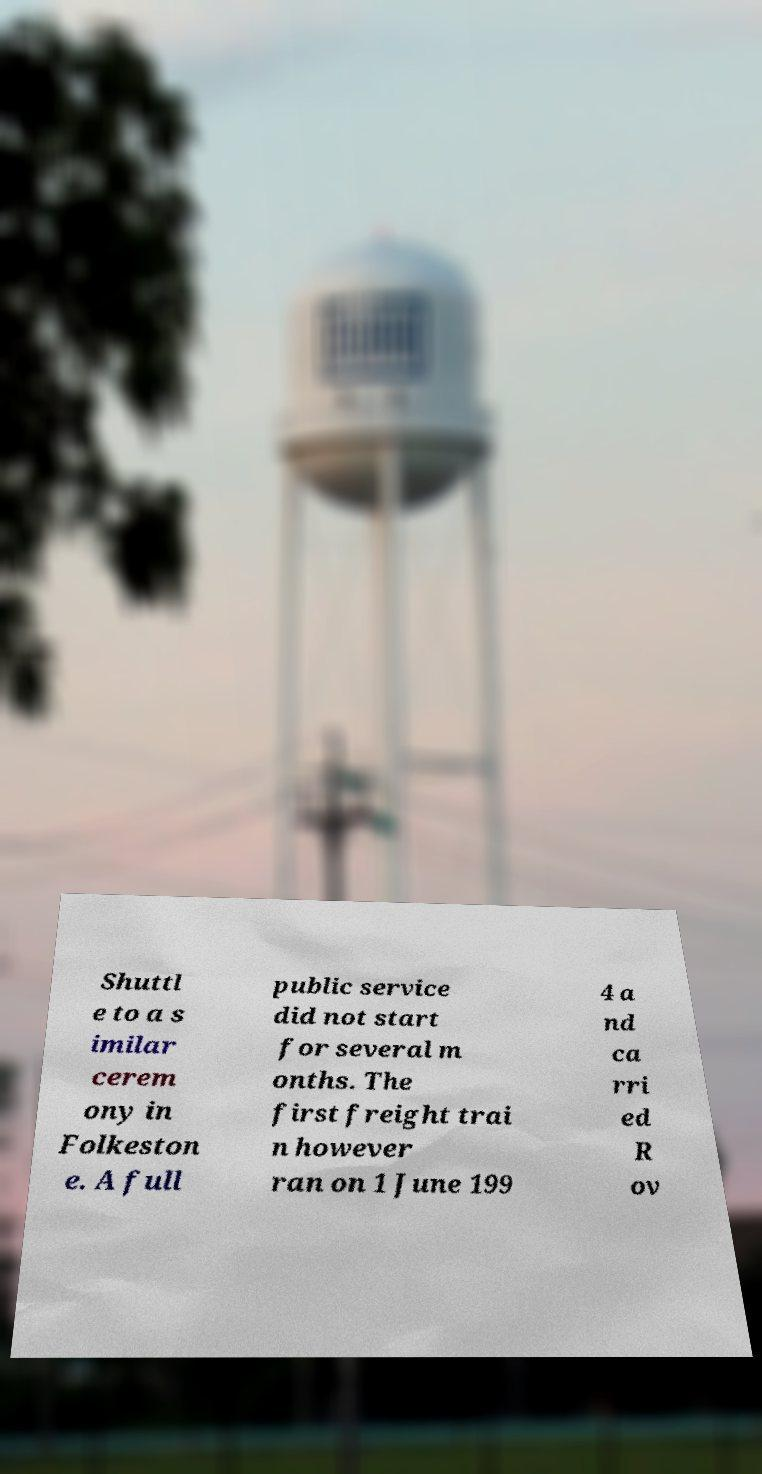Could you assist in decoding the text presented in this image and type it out clearly? Shuttl e to a s imilar cerem ony in Folkeston e. A full public service did not start for several m onths. The first freight trai n however ran on 1 June 199 4 a nd ca rri ed R ov 